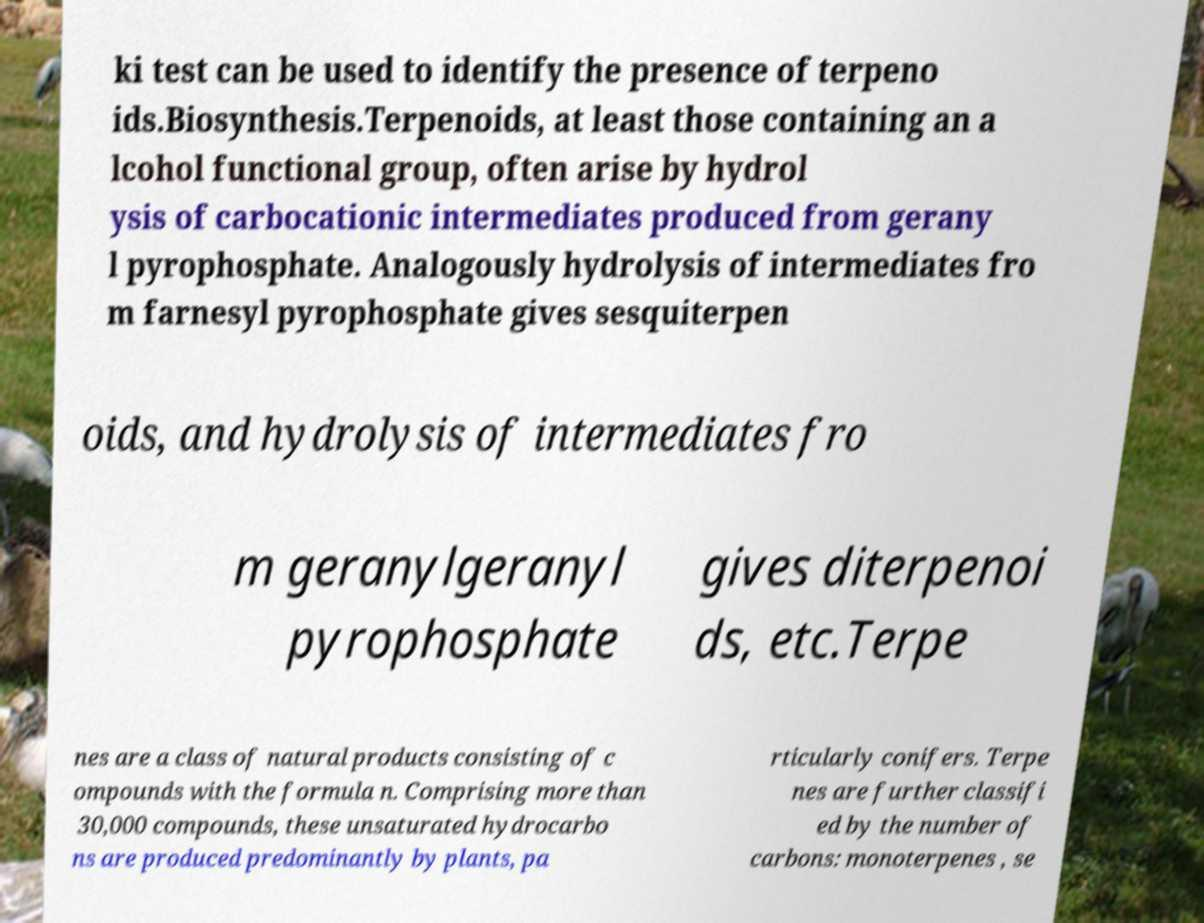Can you read and provide the text displayed in the image?This photo seems to have some interesting text. Can you extract and type it out for me? ki test can be used to identify the presence of terpeno ids.Biosynthesis.Terpenoids, at least those containing an a lcohol functional group, often arise by hydrol ysis of carbocationic intermediates produced from gerany l pyrophosphate. Analogously hydrolysis of intermediates fro m farnesyl pyrophosphate gives sesquiterpen oids, and hydrolysis of intermediates fro m geranylgeranyl pyrophosphate gives diterpenoi ds, etc.Terpe nes are a class of natural products consisting of c ompounds with the formula n. Comprising more than 30,000 compounds, these unsaturated hydrocarbo ns are produced predominantly by plants, pa rticularly conifers. Terpe nes are further classifi ed by the number of carbons: monoterpenes , se 